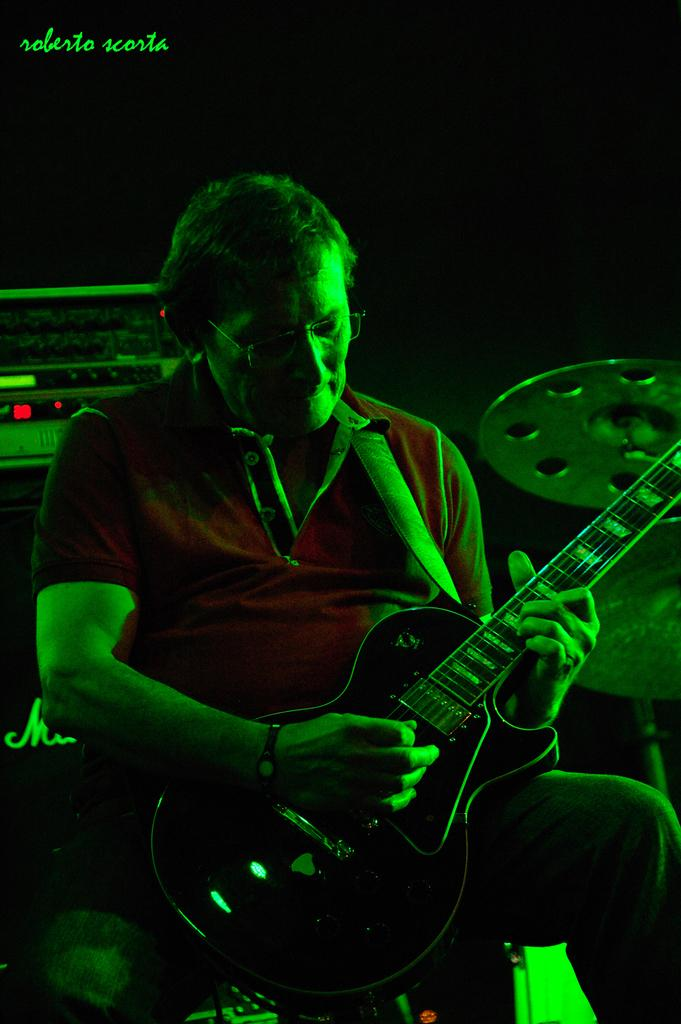What is the man in the image doing? The man is seated and playing a guitar in the image. What other musical instruments can be seen in the image? There are drums on the side and music instruments on the back in the image. Where is the text located in the image? The text is in the top left corner of the image. How many lizards are crawling on the guitar in the image? There are no lizards present in the image; the man is playing a guitar without any lizards on it. 